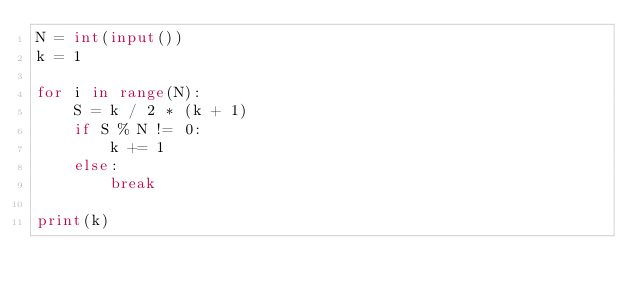<code> <loc_0><loc_0><loc_500><loc_500><_Python_>N = int(input())
k = 1

for i in range(N):
    S = k / 2 * (k + 1)
    if S % N != 0:
        k += 1
    else:
        break

print(k)</code> 